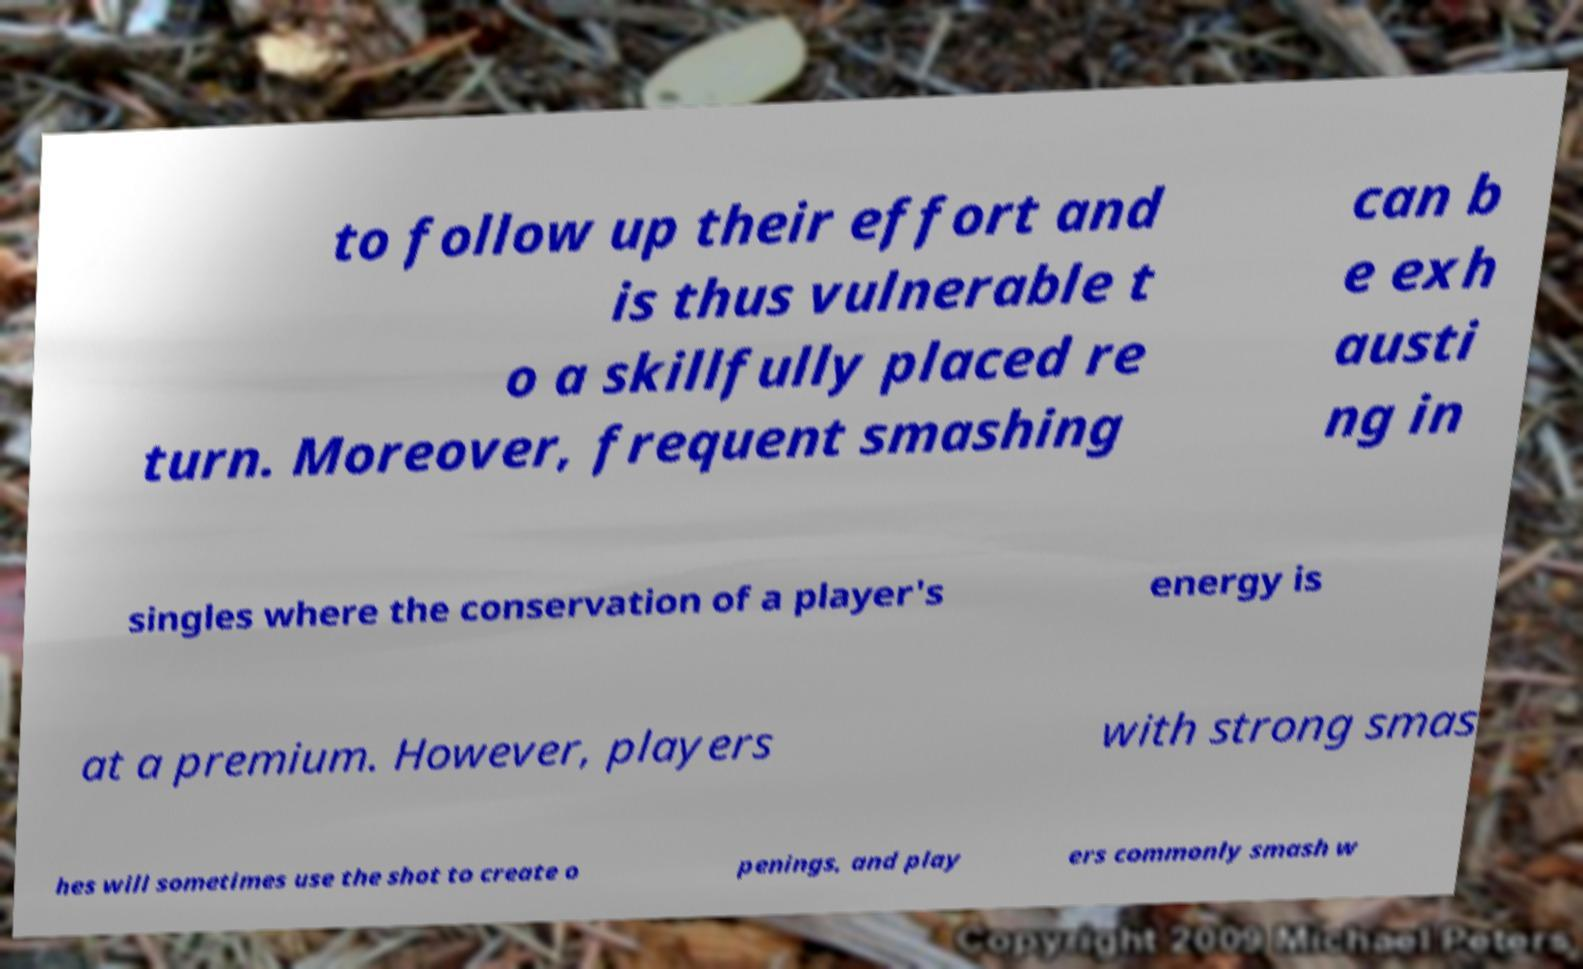I need the written content from this picture converted into text. Can you do that? to follow up their effort and is thus vulnerable t o a skillfully placed re turn. Moreover, frequent smashing can b e exh austi ng in singles where the conservation of a player's energy is at a premium. However, players with strong smas hes will sometimes use the shot to create o penings, and play ers commonly smash w 